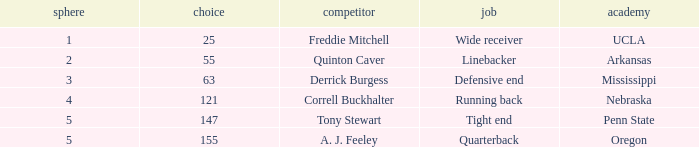What is the sum of rounds where freddie mitchell was picked? 1.0. 